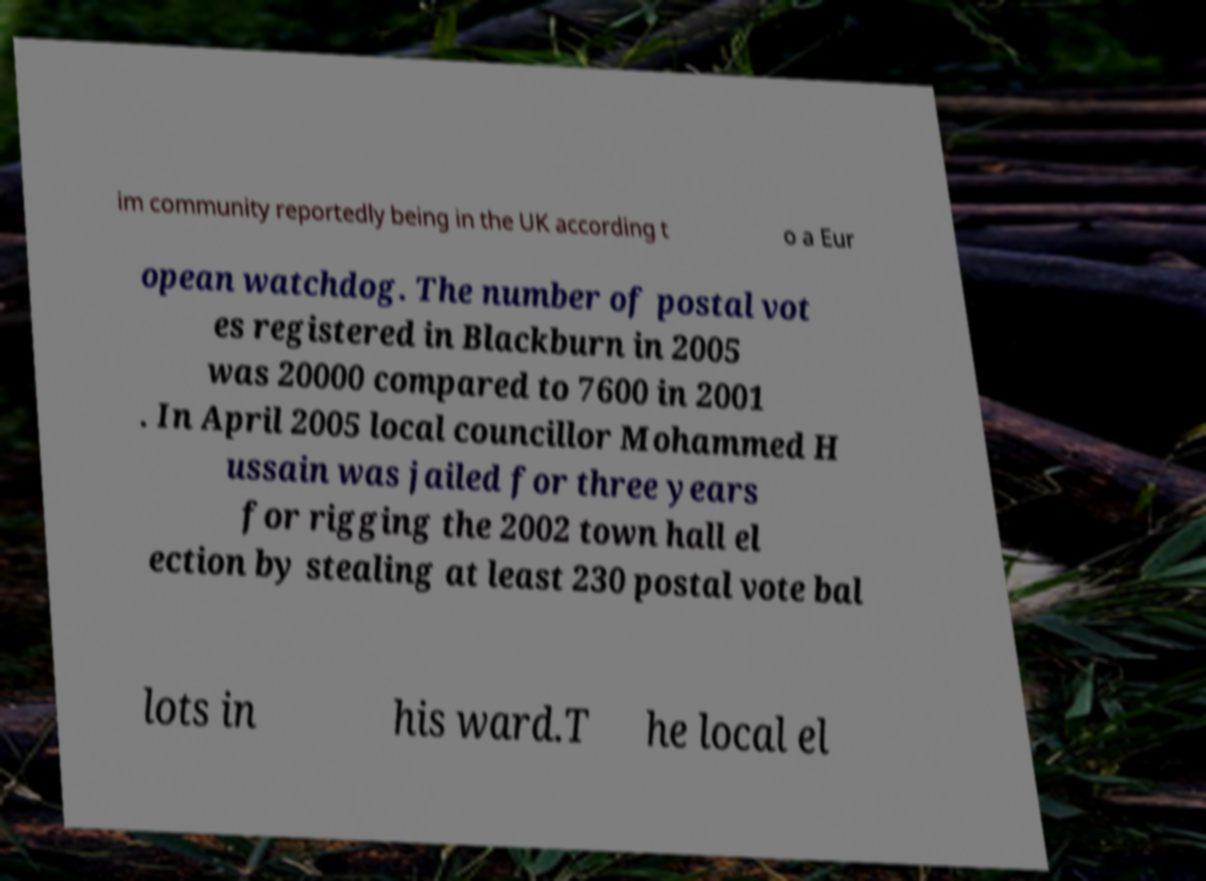Could you extract and type out the text from this image? im community reportedly being in the UK according t o a Eur opean watchdog. The number of postal vot es registered in Blackburn in 2005 was 20000 compared to 7600 in 2001 . In April 2005 local councillor Mohammed H ussain was jailed for three years for rigging the 2002 town hall el ection by stealing at least 230 postal vote bal lots in his ward.T he local el 